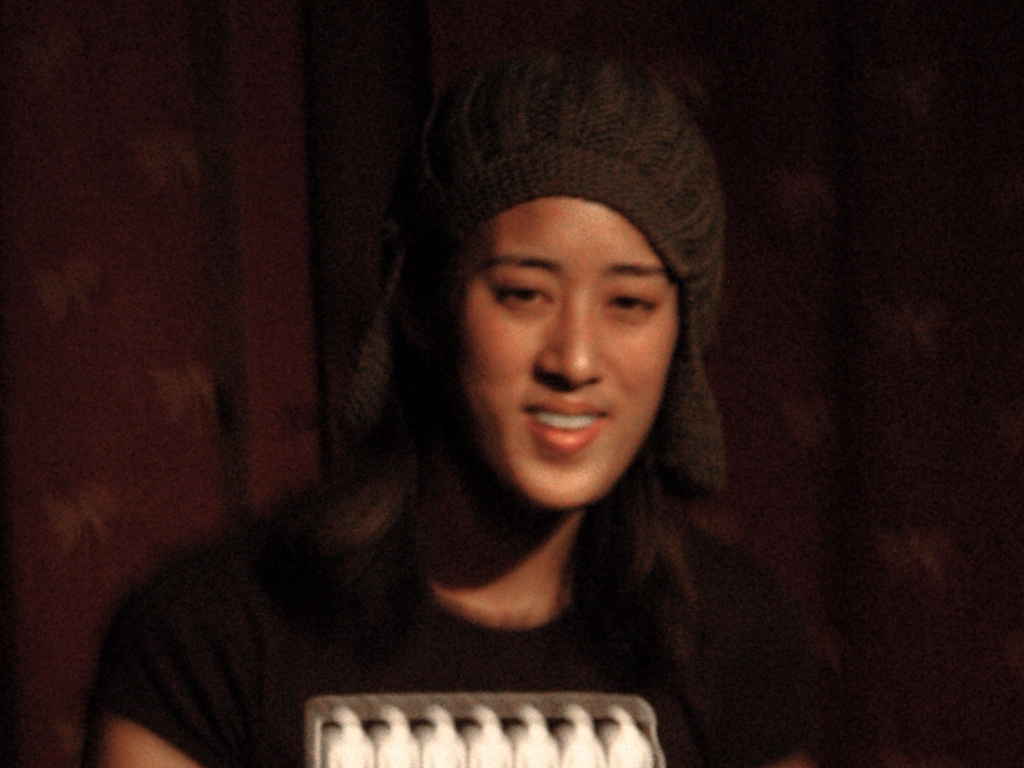Is this photo candid or posed? This photo has qualities of a candid shot, as it doesn't seem that the subject is directly interacting with the photographer. The subject appears caught in a natural moment, with a relaxed expression and informal posture typical of candid photography. 